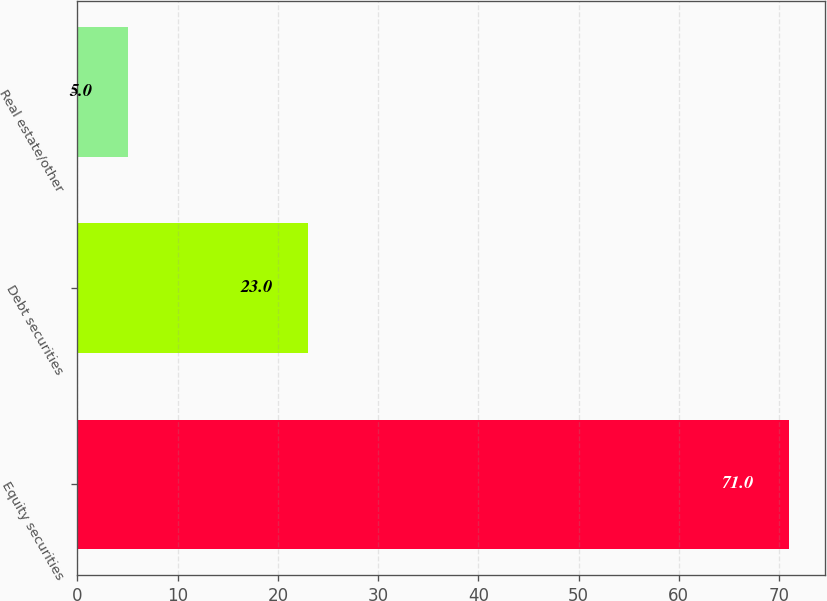Convert chart to OTSL. <chart><loc_0><loc_0><loc_500><loc_500><bar_chart><fcel>Equity securities<fcel>Debt securities<fcel>Real estate/other<nl><fcel>71<fcel>23<fcel>5<nl></chart> 